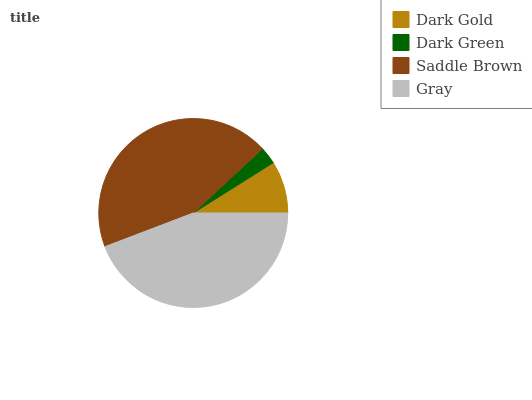Is Dark Green the minimum?
Answer yes or no. Yes. Is Gray the maximum?
Answer yes or no. Yes. Is Saddle Brown the minimum?
Answer yes or no. No. Is Saddle Brown the maximum?
Answer yes or no. No. Is Saddle Brown greater than Dark Green?
Answer yes or no. Yes. Is Dark Green less than Saddle Brown?
Answer yes or no. Yes. Is Dark Green greater than Saddle Brown?
Answer yes or no. No. Is Saddle Brown less than Dark Green?
Answer yes or no. No. Is Saddle Brown the high median?
Answer yes or no. Yes. Is Dark Gold the low median?
Answer yes or no. Yes. Is Dark Gold the high median?
Answer yes or no. No. Is Saddle Brown the low median?
Answer yes or no. No. 